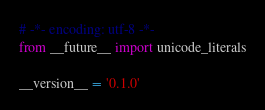Convert code to text. <code><loc_0><loc_0><loc_500><loc_500><_Python_># -*- encoding: utf-8 -*-
from __future__ import unicode_literals

__version__ = '0.1.0'
</code> 